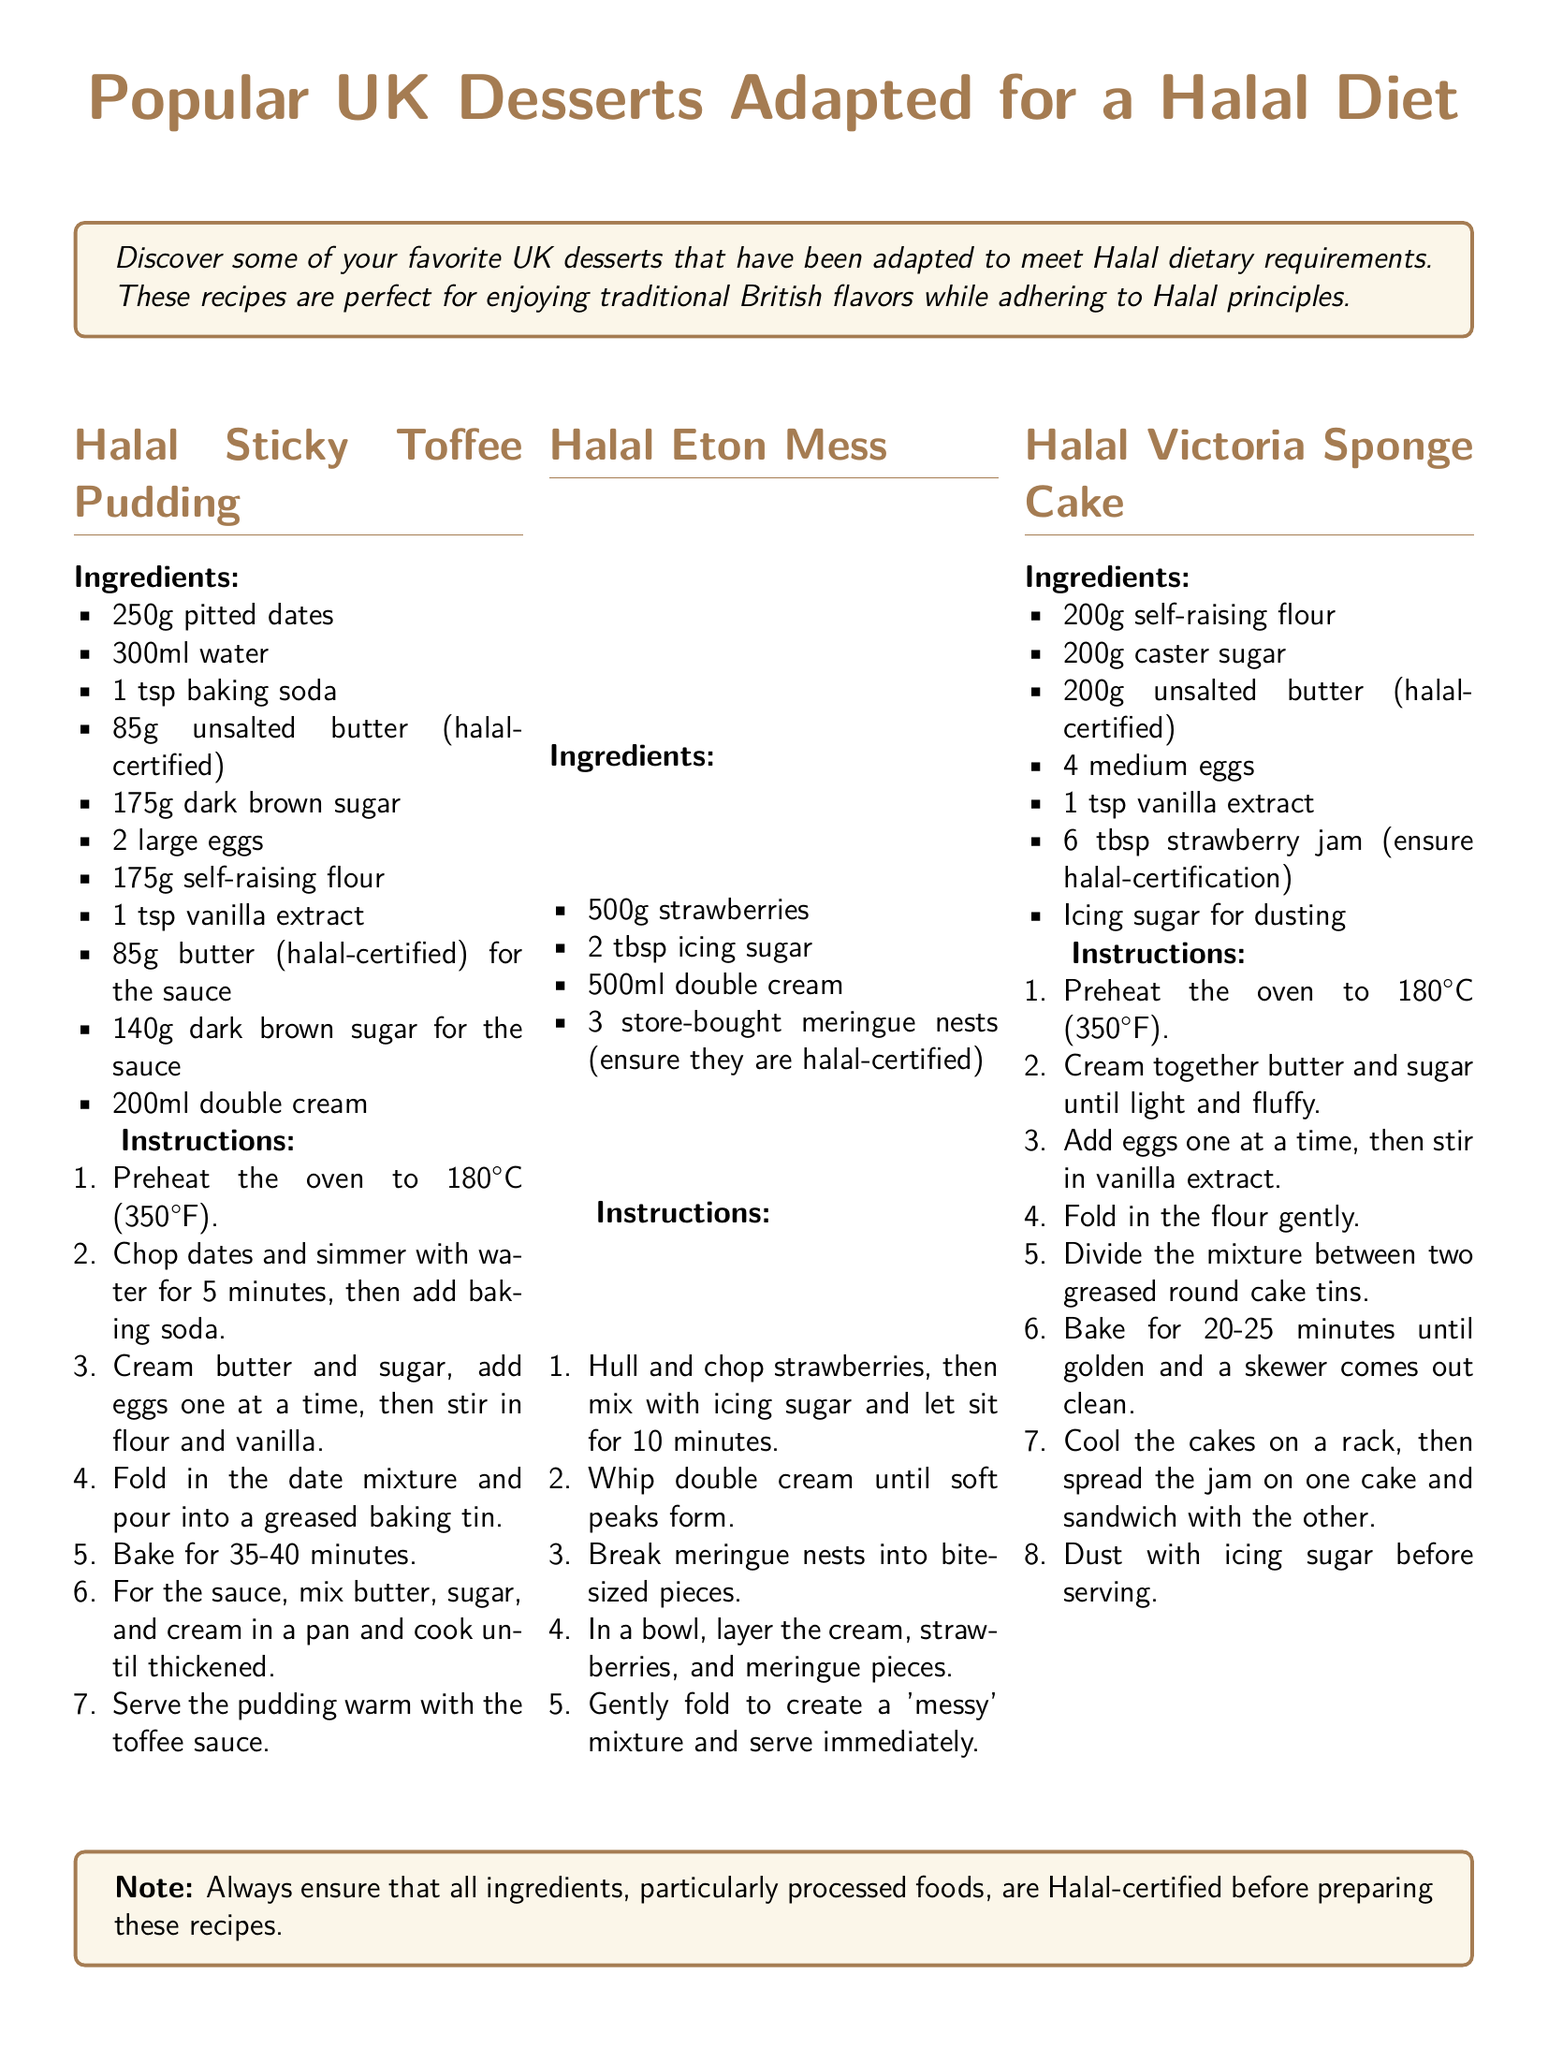What is the title of the document? The title is prominently displayed at the top of the document in a large font.
Answer: Popular UK Desserts Adapted for a Halal Diet How many ingredients are listed for Halal Sticky Toffee Pudding? The recipe section for Halal Sticky Toffee Pudding outlines a specific number of ingredients.
Answer: 10 What type of cake is featured in the document? The document includes a section specifically on one type of cake that is a popular dessert in the UK.
Answer: Victoria Sponge Cake Which dessert requires meringue nests? The recipe details in the document specify one dessert that includes meringue as an ingredient.
Answer: Halal Eton Mess What is the baking temperature for the Halal Victoria Sponge Cake? The instructions for baking the Halal Victoria Sponge Cake indicate the temperature used during cooking.
Answer: 180°C (350°F) How much double cream is needed for Halal Eton Mess? The ingredients list for Halal Eton Mess provides a specific quantity for this ingredient.
Answer: 500ml What is the purpose of the last note in the document? The last note advises on the importance of ensuring Halal certification for ingredients, especially processed foods.
Answer: To ensure Halal certification How long should the Halal Sticky Toffee Pudding be baked? The instructions for baking detail the duration for which the pudding should be in the oven.
Answer: 35-40 minutes 